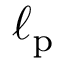Convert formula to latex. <formula><loc_0><loc_0><loc_500><loc_500>\ell _ { p }</formula> 